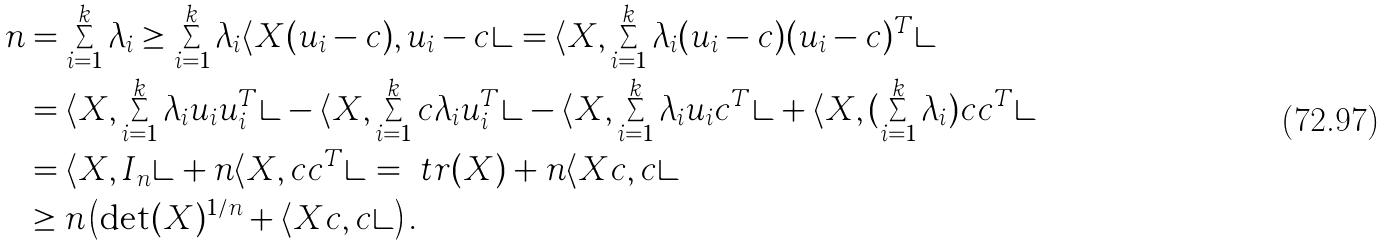<formula> <loc_0><loc_0><loc_500><loc_500>n & = \sum _ { i = 1 } ^ { k } \lambda _ { i } \geq \sum _ { i = 1 } ^ { k } \lambda _ { i } \langle { X ( u _ { i } - c ) , u _ { i } - c } \rangle = \langle { X , \sum _ { i = 1 } ^ { k } \lambda _ { i } ( u _ { i } - c ) ( u _ { i } - c ) ^ { T } } \rangle \\ & = \langle { X , \sum _ { i = 1 } ^ { k } \lambda _ { i } u _ { i } u _ { i } ^ { T } } \rangle - \langle { X , \sum _ { i = 1 } ^ { k } c \lambda _ { i } u _ { i } ^ { T } } \rangle - \langle { X , \sum _ { i = 1 } ^ { k } \lambda _ { i } u _ { i } c ^ { T } } \rangle + \langle { X , ( \sum _ { i = 1 } ^ { k } \lambda _ { i } ) c c ^ { T } } \rangle \\ & = \langle { X , I _ { n } } \rangle + n \langle { X , c c ^ { T } } \rangle = \ t r ( X ) + n \langle { X c , c } \rangle \\ & \geq n \left ( \det ( X ) ^ { 1 / n } + \langle { X c , c } \rangle \right ) .</formula> 